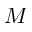Convert formula to latex. <formula><loc_0><loc_0><loc_500><loc_500>M</formula> 